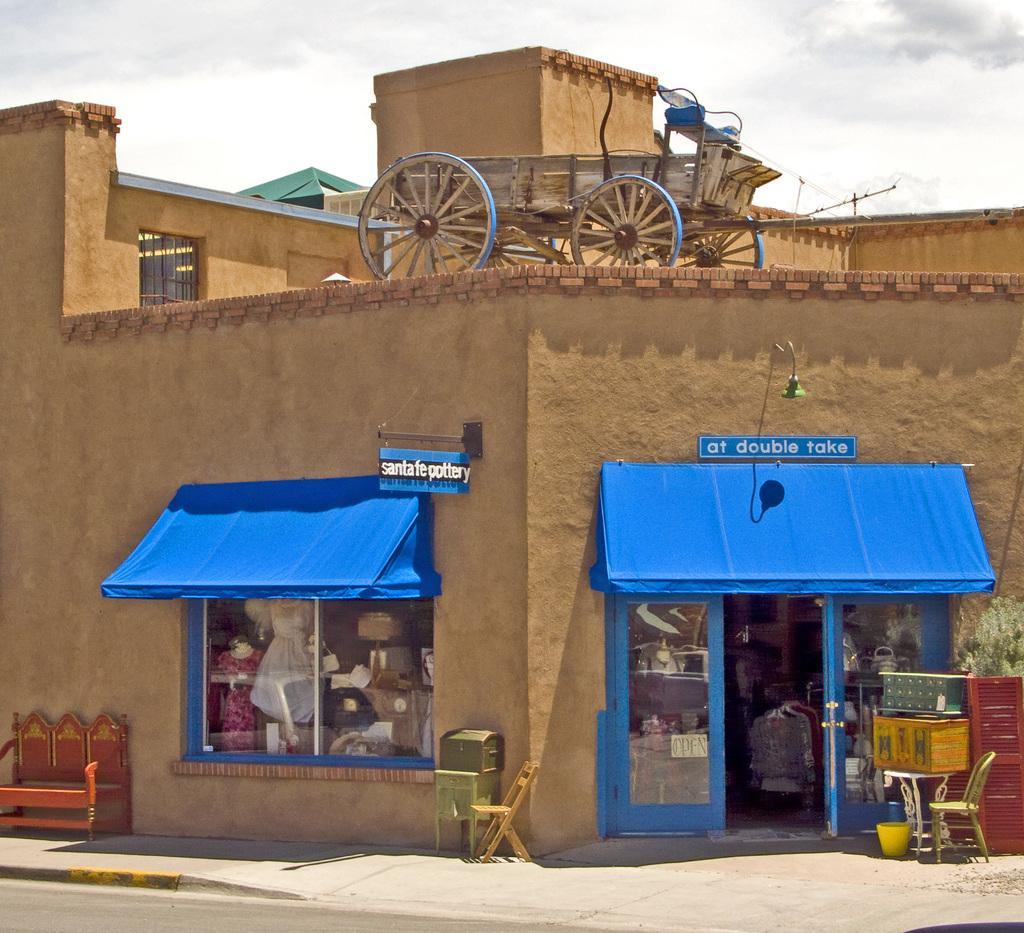Describe this image in one or two sentences. In this picture we can see the store, and the wall with some objects attached to it, we can see a cart, we can see the path and some objects on the path like, bench, chairs, trays, and we can see plant and the sky. 